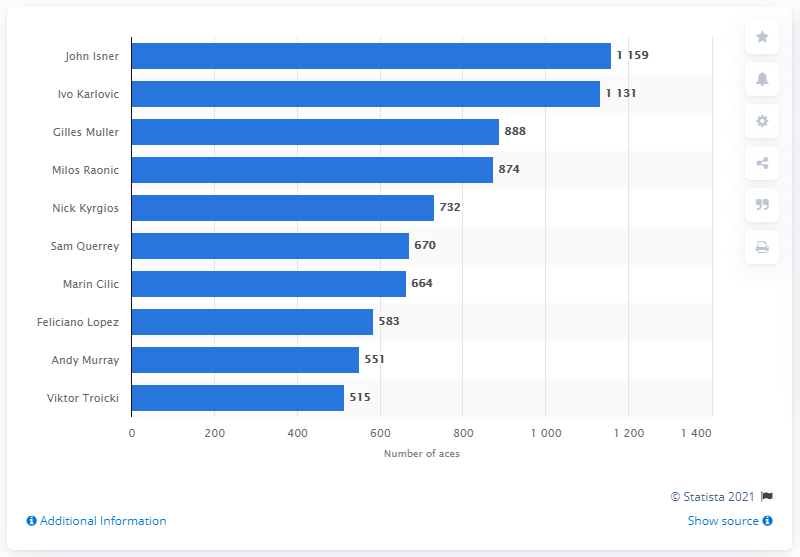Specify some key components in this picture. John Isner leads all players in a total of 1,159 aces in 50 matches. 